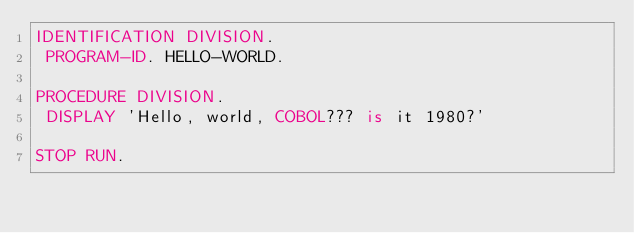<code> <loc_0><loc_0><loc_500><loc_500><_COBOL_>IDENTIFICATION DIVISION.
 PROGRAM-ID. HELLO-WORLD.

PROCEDURE DIVISION.
 DISPLAY 'Hello, world, COBOL??? is it 1980?'

STOP RUN.
</code> 